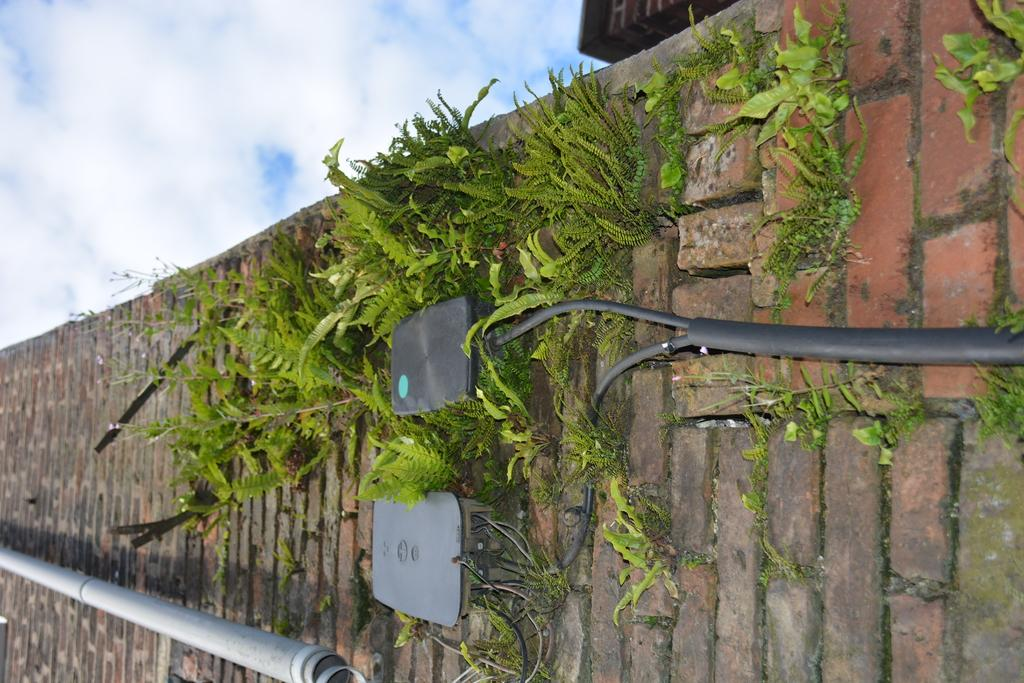What type of structure can be seen in the image? There is a wall in the image. What type of vegetation is present in the image? There are tiny plants in the image. What type of material is used for the objects in the image? There are metal objects in the image. What can be seen in the sky in the image? Clouds are visible in the sky in the image. Where is the jar placed in the image? There is no jar present in the image. What type of floor can be seen in the image? The image does not show the floor; it only shows a wall, tiny plants, metal objects, and clouds in the sky. 